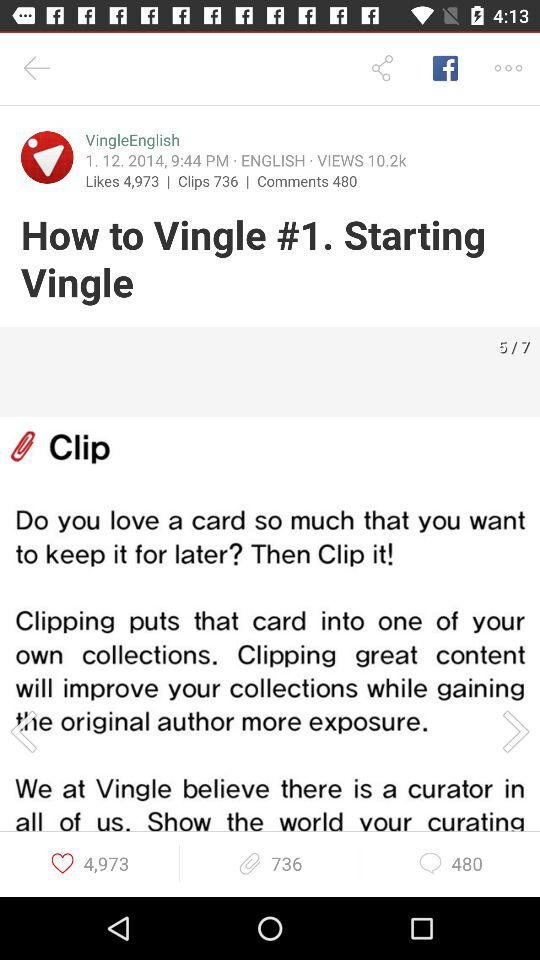How many likes are there? There are 4973 likes. 